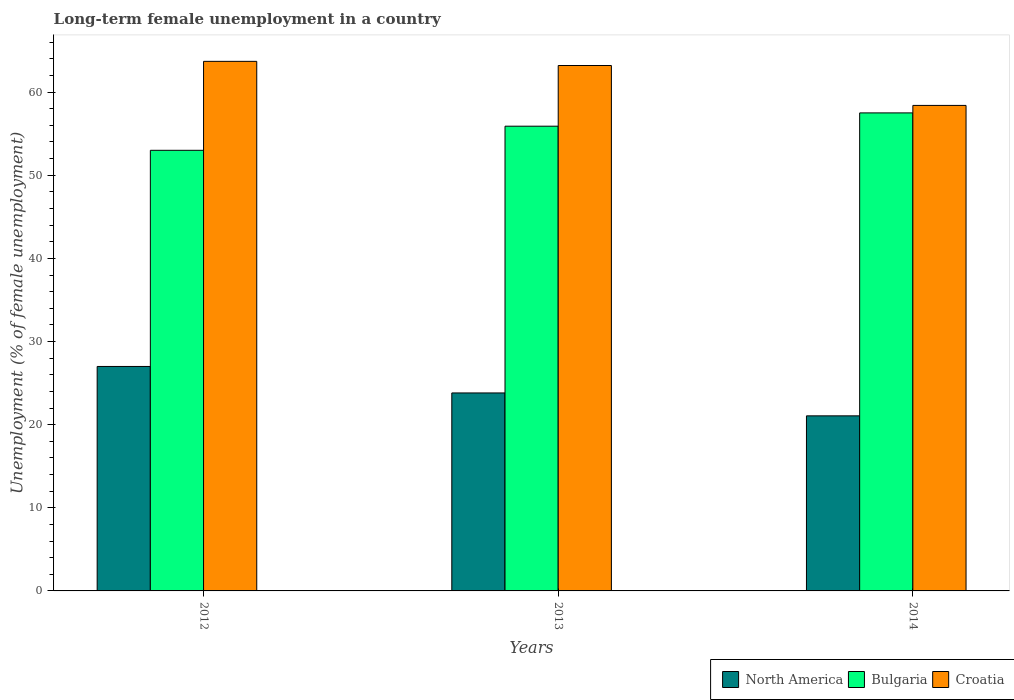How many different coloured bars are there?
Provide a short and direct response. 3. How many groups of bars are there?
Give a very brief answer. 3. How many bars are there on the 2nd tick from the right?
Keep it short and to the point. 3. In how many cases, is the number of bars for a given year not equal to the number of legend labels?
Offer a very short reply. 0. What is the percentage of long-term unemployed female population in Bulgaria in 2012?
Offer a terse response. 53. Across all years, what is the maximum percentage of long-term unemployed female population in Croatia?
Give a very brief answer. 63.7. Across all years, what is the minimum percentage of long-term unemployed female population in North America?
Provide a short and direct response. 21.06. In which year was the percentage of long-term unemployed female population in North America maximum?
Ensure brevity in your answer.  2012. What is the total percentage of long-term unemployed female population in Croatia in the graph?
Ensure brevity in your answer.  185.3. What is the difference between the percentage of long-term unemployed female population in Croatia in 2013 and that in 2014?
Give a very brief answer. 4.8. What is the difference between the percentage of long-term unemployed female population in Bulgaria in 2014 and the percentage of long-term unemployed female population in North America in 2012?
Give a very brief answer. 30.5. What is the average percentage of long-term unemployed female population in Croatia per year?
Offer a terse response. 61.77. In the year 2013, what is the difference between the percentage of long-term unemployed female population in Croatia and percentage of long-term unemployed female population in Bulgaria?
Make the answer very short. 7.3. What is the ratio of the percentage of long-term unemployed female population in Bulgaria in 2012 to that in 2014?
Your answer should be very brief. 0.92. Is the percentage of long-term unemployed female population in Croatia in 2012 less than that in 2014?
Keep it short and to the point. No. Is the difference between the percentage of long-term unemployed female population in Croatia in 2013 and 2014 greater than the difference between the percentage of long-term unemployed female population in Bulgaria in 2013 and 2014?
Your answer should be compact. Yes. What is the difference between the highest and the second highest percentage of long-term unemployed female population in North America?
Ensure brevity in your answer.  3.19. What is the difference between the highest and the lowest percentage of long-term unemployed female population in North America?
Give a very brief answer. 5.94. In how many years, is the percentage of long-term unemployed female population in Bulgaria greater than the average percentage of long-term unemployed female population in Bulgaria taken over all years?
Ensure brevity in your answer.  2. Is the sum of the percentage of long-term unemployed female population in North America in 2013 and 2014 greater than the maximum percentage of long-term unemployed female population in Bulgaria across all years?
Ensure brevity in your answer.  No. What does the 1st bar from the right in 2013 represents?
Offer a very short reply. Croatia. How many years are there in the graph?
Make the answer very short. 3. What is the difference between two consecutive major ticks on the Y-axis?
Offer a very short reply. 10. Does the graph contain any zero values?
Provide a short and direct response. No. How many legend labels are there?
Make the answer very short. 3. What is the title of the graph?
Provide a short and direct response. Long-term female unemployment in a country. Does "Euro area" appear as one of the legend labels in the graph?
Provide a short and direct response. No. What is the label or title of the X-axis?
Offer a terse response. Years. What is the label or title of the Y-axis?
Offer a very short reply. Unemployment (% of female unemployment). What is the Unemployment (% of female unemployment) in North America in 2012?
Your answer should be compact. 27. What is the Unemployment (% of female unemployment) in Croatia in 2012?
Offer a very short reply. 63.7. What is the Unemployment (% of female unemployment) of North America in 2013?
Ensure brevity in your answer.  23.81. What is the Unemployment (% of female unemployment) in Bulgaria in 2013?
Ensure brevity in your answer.  55.9. What is the Unemployment (% of female unemployment) in Croatia in 2013?
Your answer should be very brief. 63.2. What is the Unemployment (% of female unemployment) of North America in 2014?
Provide a succinct answer. 21.06. What is the Unemployment (% of female unemployment) of Bulgaria in 2014?
Provide a succinct answer. 57.5. What is the Unemployment (% of female unemployment) of Croatia in 2014?
Provide a short and direct response. 58.4. Across all years, what is the maximum Unemployment (% of female unemployment) of North America?
Offer a very short reply. 27. Across all years, what is the maximum Unemployment (% of female unemployment) in Bulgaria?
Ensure brevity in your answer.  57.5. Across all years, what is the maximum Unemployment (% of female unemployment) in Croatia?
Offer a terse response. 63.7. Across all years, what is the minimum Unemployment (% of female unemployment) of North America?
Offer a terse response. 21.06. Across all years, what is the minimum Unemployment (% of female unemployment) in Bulgaria?
Provide a succinct answer. 53. Across all years, what is the minimum Unemployment (% of female unemployment) of Croatia?
Provide a short and direct response. 58.4. What is the total Unemployment (% of female unemployment) of North America in the graph?
Keep it short and to the point. 71.87. What is the total Unemployment (% of female unemployment) in Bulgaria in the graph?
Provide a short and direct response. 166.4. What is the total Unemployment (% of female unemployment) of Croatia in the graph?
Offer a very short reply. 185.3. What is the difference between the Unemployment (% of female unemployment) in North America in 2012 and that in 2013?
Provide a succinct answer. 3.19. What is the difference between the Unemployment (% of female unemployment) in Bulgaria in 2012 and that in 2013?
Provide a short and direct response. -2.9. What is the difference between the Unemployment (% of female unemployment) in North America in 2012 and that in 2014?
Your answer should be very brief. 5.94. What is the difference between the Unemployment (% of female unemployment) in North America in 2013 and that in 2014?
Your answer should be very brief. 2.75. What is the difference between the Unemployment (% of female unemployment) of Croatia in 2013 and that in 2014?
Your response must be concise. 4.8. What is the difference between the Unemployment (% of female unemployment) in North America in 2012 and the Unemployment (% of female unemployment) in Bulgaria in 2013?
Keep it short and to the point. -28.9. What is the difference between the Unemployment (% of female unemployment) in North America in 2012 and the Unemployment (% of female unemployment) in Croatia in 2013?
Offer a terse response. -36.2. What is the difference between the Unemployment (% of female unemployment) in North America in 2012 and the Unemployment (% of female unemployment) in Bulgaria in 2014?
Ensure brevity in your answer.  -30.5. What is the difference between the Unemployment (% of female unemployment) of North America in 2012 and the Unemployment (% of female unemployment) of Croatia in 2014?
Keep it short and to the point. -31.4. What is the difference between the Unemployment (% of female unemployment) of Bulgaria in 2012 and the Unemployment (% of female unemployment) of Croatia in 2014?
Offer a terse response. -5.4. What is the difference between the Unemployment (% of female unemployment) of North America in 2013 and the Unemployment (% of female unemployment) of Bulgaria in 2014?
Your answer should be compact. -33.69. What is the difference between the Unemployment (% of female unemployment) of North America in 2013 and the Unemployment (% of female unemployment) of Croatia in 2014?
Provide a succinct answer. -34.59. What is the average Unemployment (% of female unemployment) of North America per year?
Keep it short and to the point. 23.96. What is the average Unemployment (% of female unemployment) in Bulgaria per year?
Make the answer very short. 55.47. What is the average Unemployment (% of female unemployment) of Croatia per year?
Your answer should be very brief. 61.77. In the year 2012, what is the difference between the Unemployment (% of female unemployment) of North America and Unemployment (% of female unemployment) of Bulgaria?
Your answer should be compact. -26. In the year 2012, what is the difference between the Unemployment (% of female unemployment) of North America and Unemployment (% of female unemployment) of Croatia?
Keep it short and to the point. -36.7. In the year 2012, what is the difference between the Unemployment (% of female unemployment) of Bulgaria and Unemployment (% of female unemployment) of Croatia?
Provide a succinct answer. -10.7. In the year 2013, what is the difference between the Unemployment (% of female unemployment) of North America and Unemployment (% of female unemployment) of Bulgaria?
Provide a succinct answer. -32.09. In the year 2013, what is the difference between the Unemployment (% of female unemployment) in North America and Unemployment (% of female unemployment) in Croatia?
Provide a short and direct response. -39.39. In the year 2013, what is the difference between the Unemployment (% of female unemployment) in Bulgaria and Unemployment (% of female unemployment) in Croatia?
Your response must be concise. -7.3. In the year 2014, what is the difference between the Unemployment (% of female unemployment) in North America and Unemployment (% of female unemployment) in Bulgaria?
Offer a terse response. -36.44. In the year 2014, what is the difference between the Unemployment (% of female unemployment) of North America and Unemployment (% of female unemployment) of Croatia?
Make the answer very short. -37.34. In the year 2014, what is the difference between the Unemployment (% of female unemployment) of Bulgaria and Unemployment (% of female unemployment) of Croatia?
Your response must be concise. -0.9. What is the ratio of the Unemployment (% of female unemployment) of North America in 2012 to that in 2013?
Offer a terse response. 1.13. What is the ratio of the Unemployment (% of female unemployment) in Bulgaria in 2012 to that in 2013?
Your answer should be compact. 0.95. What is the ratio of the Unemployment (% of female unemployment) in Croatia in 2012 to that in 2013?
Give a very brief answer. 1.01. What is the ratio of the Unemployment (% of female unemployment) in North America in 2012 to that in 2014?
Provide a short and direct response. 1.28. What is the ratio of the Unemployment (% of female unemployment) of Bulgaria in 2012 to that in 2014?
Offer a terse response. 0.92. What is the ratio of the Unemployment (% of female unemployment) of Croatia in 2012 to that in 2014?
Make the answer very short. 1.09. What is the ratio of the Unemployment (% of female unemployment) in North America in 2013 to that in 2014?
Provide a short and direct response. 1.13. What is the ratio of the Unemployment (% of female unemployment) in Bulgaria in 2013 to that in 2014?
Offer a terse response. 0.97. What is the ratio of the Unemployment (% of female unemployment) of Croatia in 2013 to that in 2014?
Give a very brief answer. 1.08. What is the difference between the highest and the second highest Unemployment (% of female unemployment) in North America?
Your response must be concise. 3.19. What is the difference between the highest and the lowest Unemployment (% of female unemployment) in North America?
Your response must be concise. 5.94. What is the difference between the highest and the lowest Unemployment (% of female unemployment) of Bulgaria?
Keep it short and to the point. 4.5. 